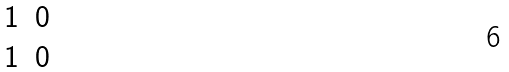Convert formula to latex. <formula><loc_0><loc_0><loc_500><loc_500>\begin{matrix} 1 & 0 \\ 1 & 0 \end{matrix}</formula> 